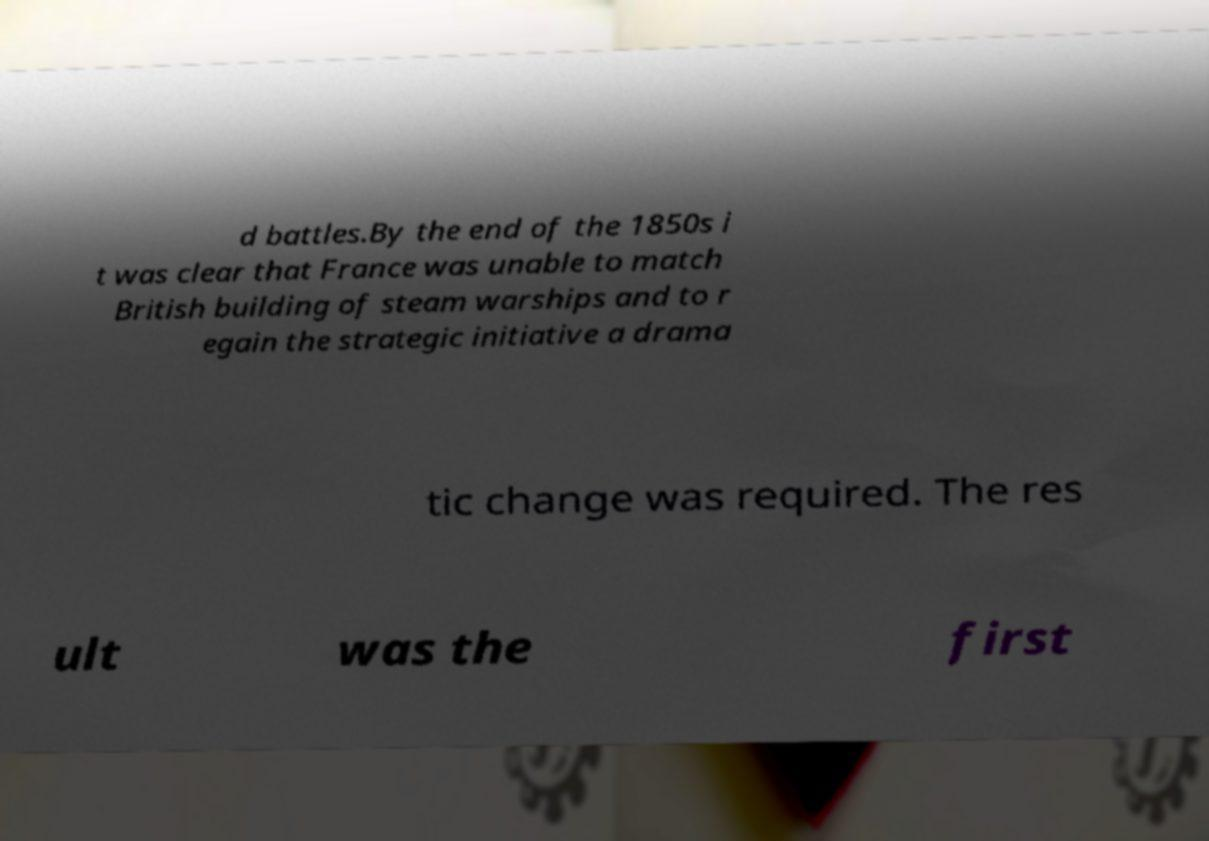Could you assist in decoding the text presented in this image and type it out clearly? d battles.By the end of the 1850s i t was clear that France was unable to match British building of steam warships and to r egain the strategic initiative a drama tic change was required. The res ult was the first 